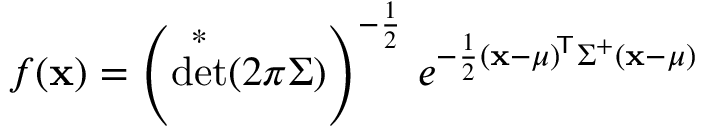<formula> <loc_0><loc_0><loc_500><loc_500>f ( x ) = \left ( \det ^ { * } ( 2 \pi { \Sigma } ) \right ) ^ { - { \frac { 1 } { 2 } } } \, e ^ { - { \frac { 1 } { 2 } } ( x - { \mu } ) ^ { \, { T } } { \Sigma } ^ { + } ( x - { \mu } ) }</formula> 